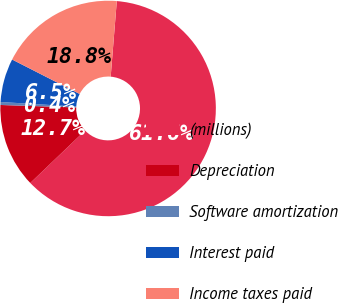<chart> <loc_0><loc_0><loc_500><loc_500><pie_chart><fcel>(millions)<fcel>Depreciation<fcel>Software amortization<fcel>Interest paid<fcel>Income taxes paid<nl><fcel>61.56%<fcel>12.67%<fcel>0.44%<fcel>6.55%<fcel>18.78%<nl></chart> 